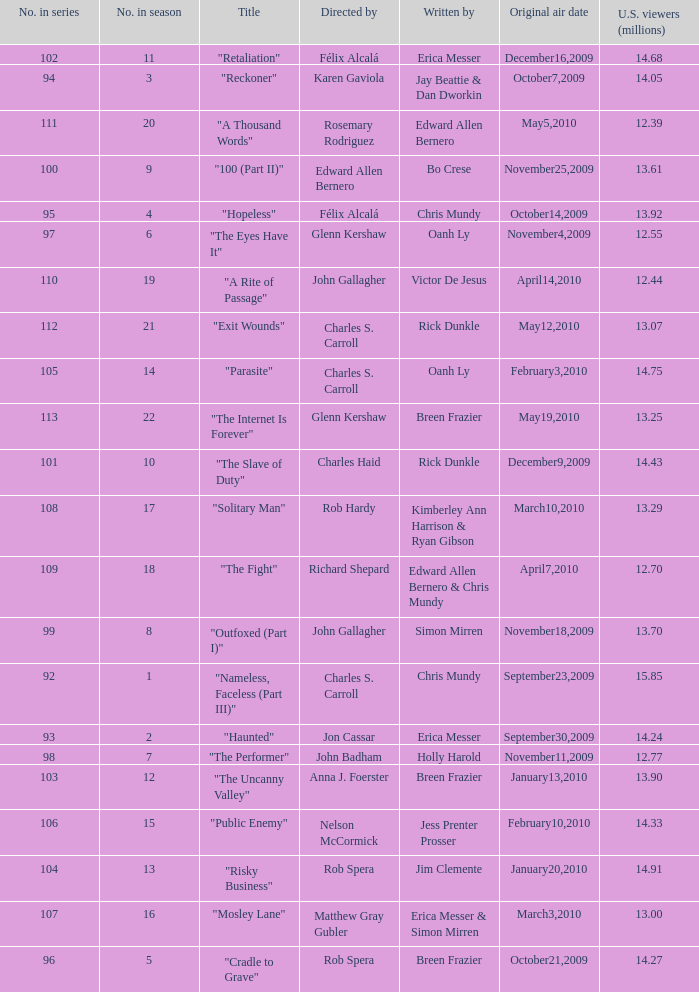What season was the episode "haunted" in? 2.0. Can you parse all the data within this table? {'header': ['No. in series', 'No. in season', 'Title', 'Directed by', 'Written by', 'Original air date', 'U.S. viewers (millions)'], 'rows': [['102', '11', '"Retaliation"', 'Félix Alcalá', 'Erica Messer', 'December16,2009', '14.68'], ['94', '3', '"Reckoner"', 'Karen Gaviola', 'Jay Beattie & Dan Dworkin', 'October7,2009', '14.05'], ['111', '20', '"A Thousand Words"', 'Rosemary Rodriguez', 'Edward Allen Bernero', 'May5,2010', '12.39'], ['100', '9', '"100 (Part II)"', 'Edward Allen Bernero', 'Bo Crese', 'November25,2009', '13.61'], ['95', '4', '"Hopeless"', 'Félix Alcalá', 'Chris Mundy', 'October14,2009', '13.92'], ['97', '6', '"The Eyes Have It"', 'Glenn Kershaw', 'Oanh Ly', 'November4,2009', '12.55'], ['110', '19', '"A Rite of Passage"', 'John Gallagher', 'Victor De Jesus', 'April14,2010', '12.44'], ['112', '21', '"Exit Wounds"', 'Charles S. Carroll', 'Rick Dunkle', 'May12,2010', '13.07'], ['105', '14', '"Parasite"', 'Charles S. Carroll', 'Oanh Ly', 'February3,2010', '14.75'], ['113', '22', '"The Internet Is Forever"', 'Glenn Kershaw', 'Breen Frazier', 'May19,2010', '13.25'], ['101', '10', '"The Slave of Duty"', 'Charles Haid', 'Rick Dunkle', 'December9,2009', '14.43'], ['108', '17', '"Solitary Man"', 'Rob Hardy', 'Kimberley Ann Harrison & Ryan Gibson', 'March10,2010', '13.29'], ['109', '18', '"The Fight"', 'Richard Shepard', 'Edward Allen Bernero & Chris Mundy', 'April7,2010', '12.70'], ['99', '8', '"Outfoxed (Part I)"', 'John Gallagher', 'Simon Mirren', 'November18,2009', '13.70'], ['92', '1', '"Nameless, Faceless (Part III)"', 'Charles S. Carroll', 'Chris Mundy', 'September23,2009', '15.85'], ['93', '2', '"Haunted"', 'Jon Cassar', 'Erica Messer', 'September30,2009', '14.24'], ['98', '7', '"The Performer"', 'John Badham', 'Holly Harold', 'November11,2009', '12.77'], ['103', '12', '"The Uncanny Valley"', 'Anna J. Foerster', 'Breen Frazier', 'January13,2010', '13.90'], ['106', '15', '"Public Enemy"', 'Nelson McCormick', 'Jess Prenter Prosser', 'February10,2010', '14.33'], ['104', '13', '"Risky Business"', 'Rob Spera', 'Jim Clemente', 'January20,2010', '14.91'], ['107', '16', '"Mosley Lane"', 'Matthew Gray Gubler', 'Erica Messer & Simon Mirren', 'March3,2010', '13.00'], ['96', '5', '"Cradle to Grave"', 'Rob Spera', 'Breen Frazier', 'October21,2009', '14.27']]} 